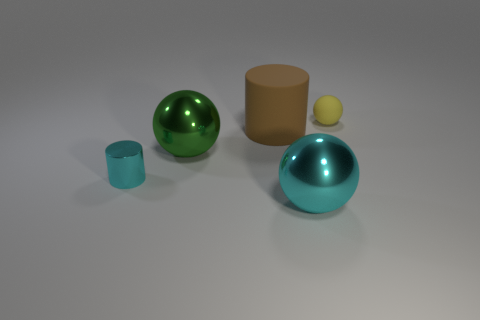Subtract all gray cylinders. Subtract all green cubes. How many cylinders are left? 2 Add 2 tiny cyan rubber balls. How many objects exist? 7 Subtract all cylinders. How many objects are left? 3 Subtract all big metal cylinders. Subtract all large cyan metal objects. How many objects are left? 4 Add 5 tiny yellow rubber balls. How many tiny yellow rubber balls are left? 6 Add 2 tiny metallic cylinders. How many tiny metallic cylinders exist? 3 Subtract 1 brown cylinders. How many objects are left? 4 